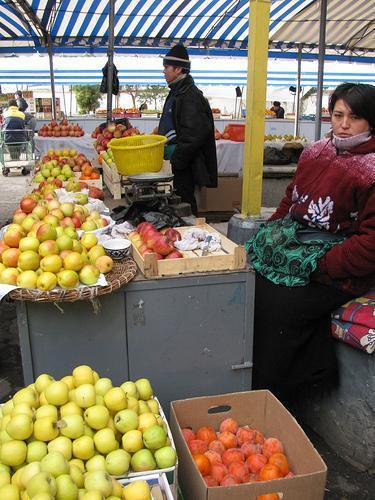How many apples are there?
Give a very brief answer. 2. How many people are there?
Give a very brief answer. 2. How many blue cars are there?
Give a very brief answer. 0. 